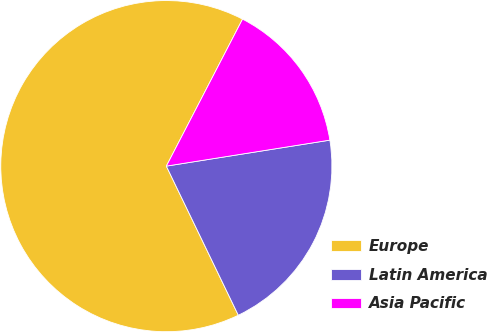Convert chart to OTSL. <chart><loc_0><loc_0><loc_500><loc_500><pie_chart><fcel>Europe<fcel>Latin America<fcel>Asia Pacific<nl><fcel>64.77%<fcel>20.35%<fcel>14.88%<nl></chart> 